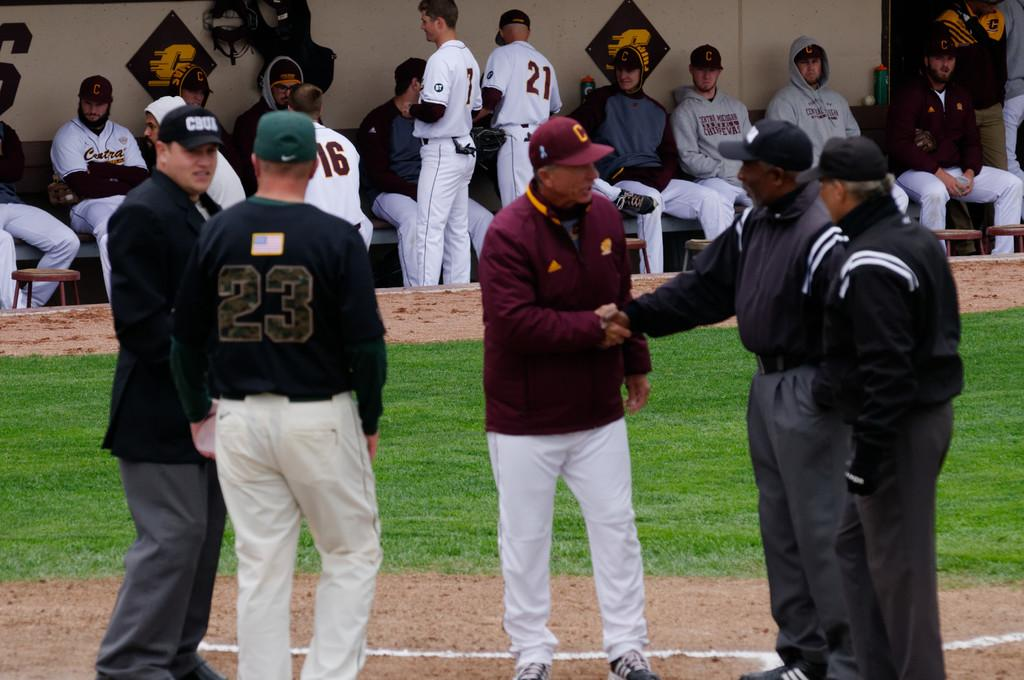<image>
Summarize the visual content of the image. some players with one in black the number 23 on the jersey 